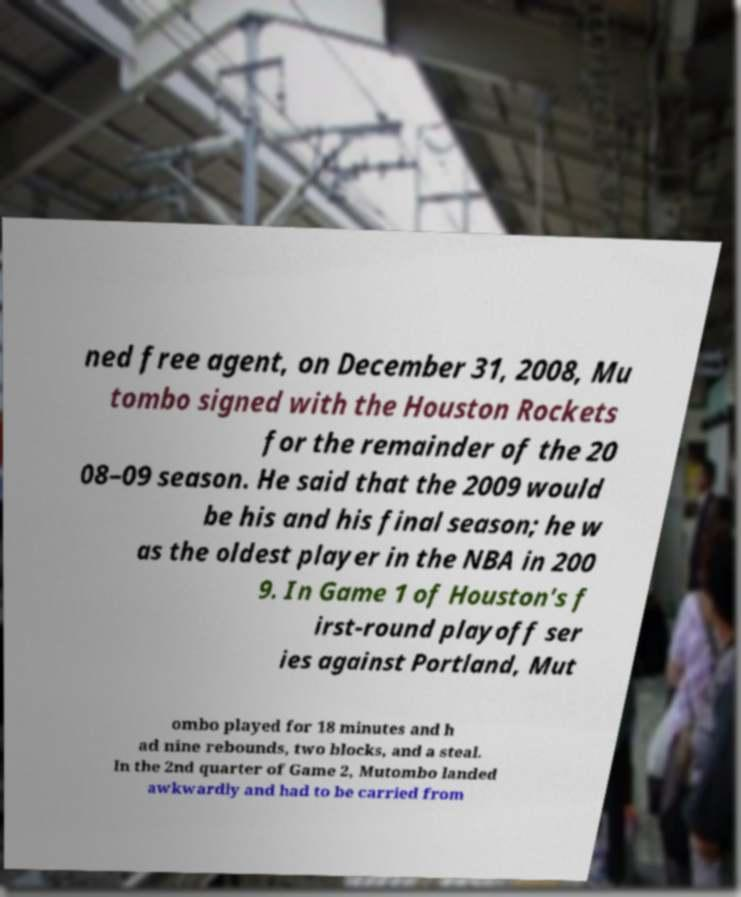What messages or text are displayed in this image? I need them in a readable, typed format. ned free agent, on December 31, 2008, Mu tombo signed with the Houston Rockets for the remainder of the 20 08–09 season. He said that the 2009 would be his and his final season; he w as the oldest player in the NBA in 200 9. In Game 1 of Houston's f irst-round playoff ser ies against Portland, Mut ombo played for 18 minutes and h ad nine rebounds, two blocks, and a steal. In the 2nd quarter of Game 2, Mutombo landed awkwardly and had to be carried from 